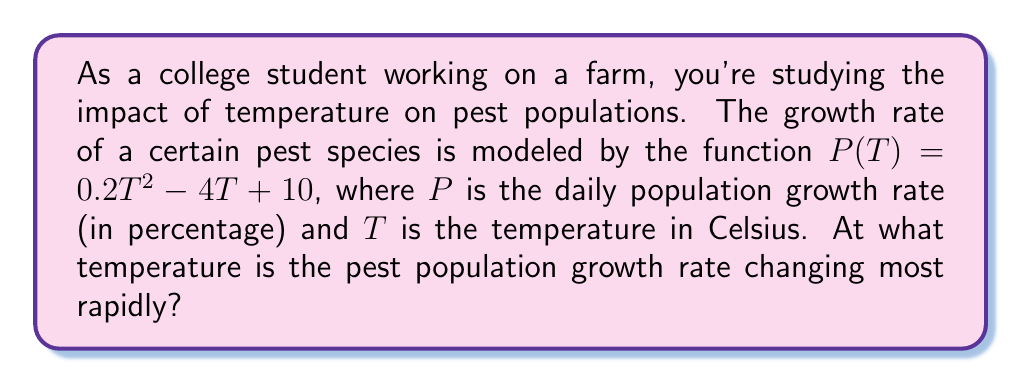Teach me how to tackle this problem. To find the temperature at which the pest population growth rate is changing most rapidly, we need to find the maximum absolute value of the derivative of $P(T)$.

Step 1: Find the derivative of $P(T)$.
$$P'(T) = \frac{d}{dT}(0.2T^2 - 4T + 10) = 0.4T - 4$$

Step 2: The rate of change is most rapid where $|P'(T)|$ is at its maximum. Since $P'(T)$ is a linear function, its absolute value will be greatest at the endpoints of the temperature range or where $P'(T) = 0$.

Step 3: Find where $P'(T) = 0$:
$$0.4T - 4 = 0$$
$$0.4T = 4$$
$$T = 10$$

Step 4: At $T = 10°C$, $P'(10) = 0$, which means the growth rate is neither increasing nor decreasing most rapidly at this point.

Step 5: As $T$ increases beyond $10°C$, $P'(T)$ becomes positive and increases, while for $T < 10°C$, $P'(T)$ is negative and decreases. The absolute value of $P'(T)$ will be largest at the extreme temperatures in the viable range for the pests.

Step 6: Since we're not given a specific temperature range, we can conclude that the pest population growth rate is changing most rapidly at the highest or lowest temperatures at which the pests can survive.
Answer: At extreme temperatures (highest or lowest viable for pests) 